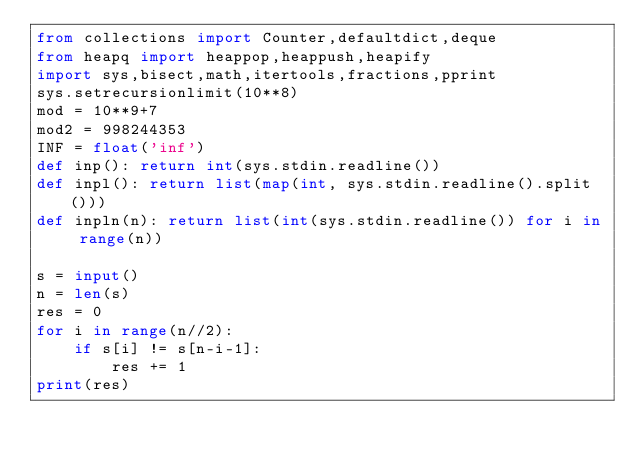Convert code to text. <code><loc_0><loc_0><loc_500><loc_500><_Python_>from collections import Counter,defaultdict,deque
from heapq import heappop,heappush,heapify
import sys,bisect,math,itertools,fractions,pprint
sys.setrecursionlimit(10**8)
mod = 10**9+7
mod2 = 998244353
INF = float('inf')
def inp(): return int(sys.stdin.readline())
def inpl(): return list(map(int, sys.stdin.readline().split()))
def inpln(n): return list(int(sys.stdin.readline()) for i in range(n))

s = input()
n = len(s)
res = 0
for i in range(n//2):
    if s[i] != s[n-i-1]:
        res += 1
print(res)</code> 